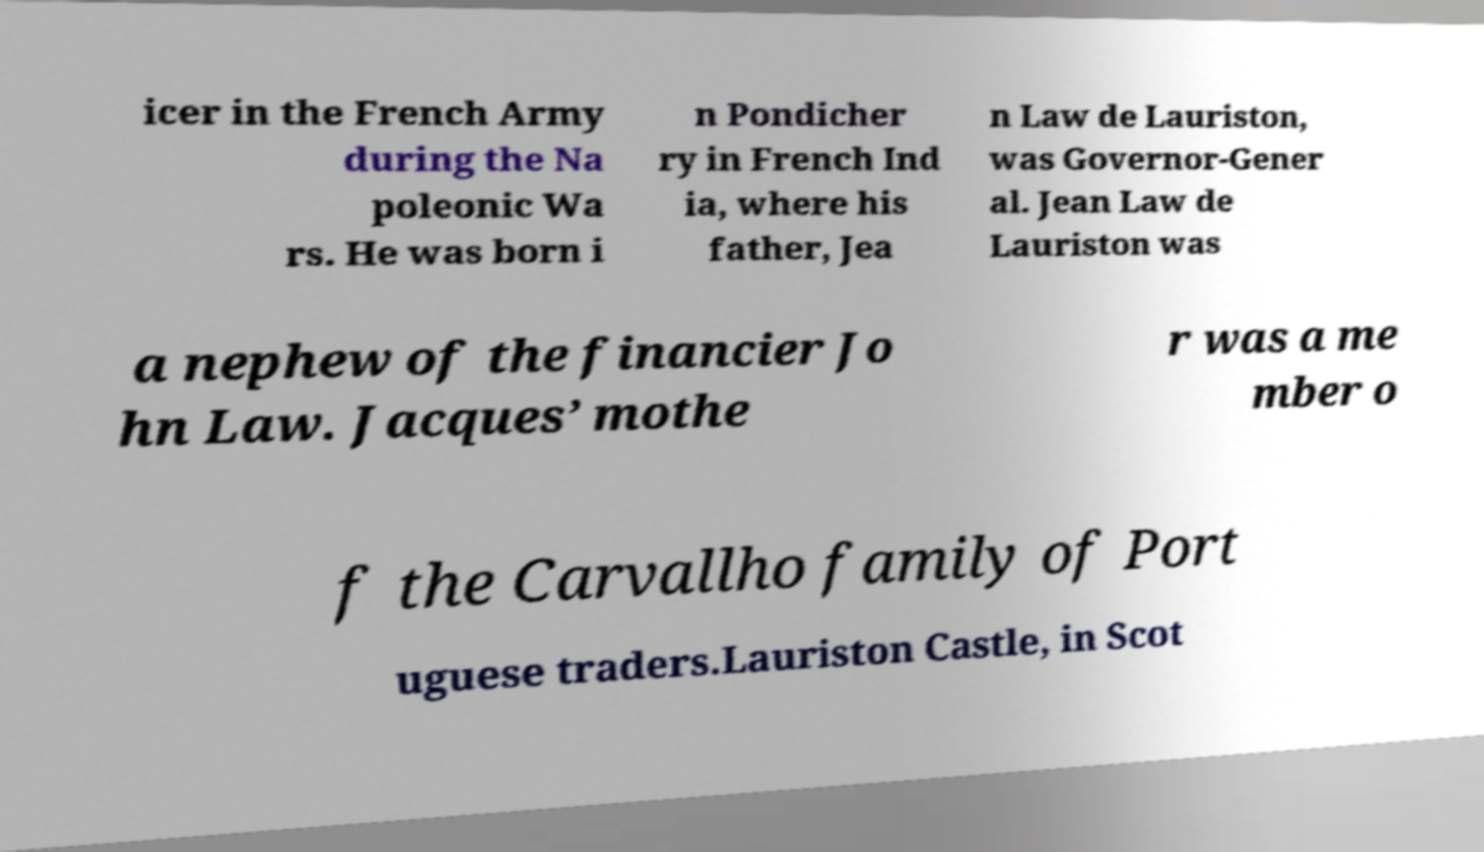Could you extract and type out the text from this image? icer in the French Army during the Na poleonic Wa rs. He was born i n Pondicher ry in French Ind ia, where his father, Jea n Law de Lauriston, was Governor-Gener al. Jean Law de Lauriston was a nephew of the financier Jo hn Law. Jacques’ mothe r was a me mber o f the Carvallho family of Port uguese traders.Lauriston Castle, in Scot 